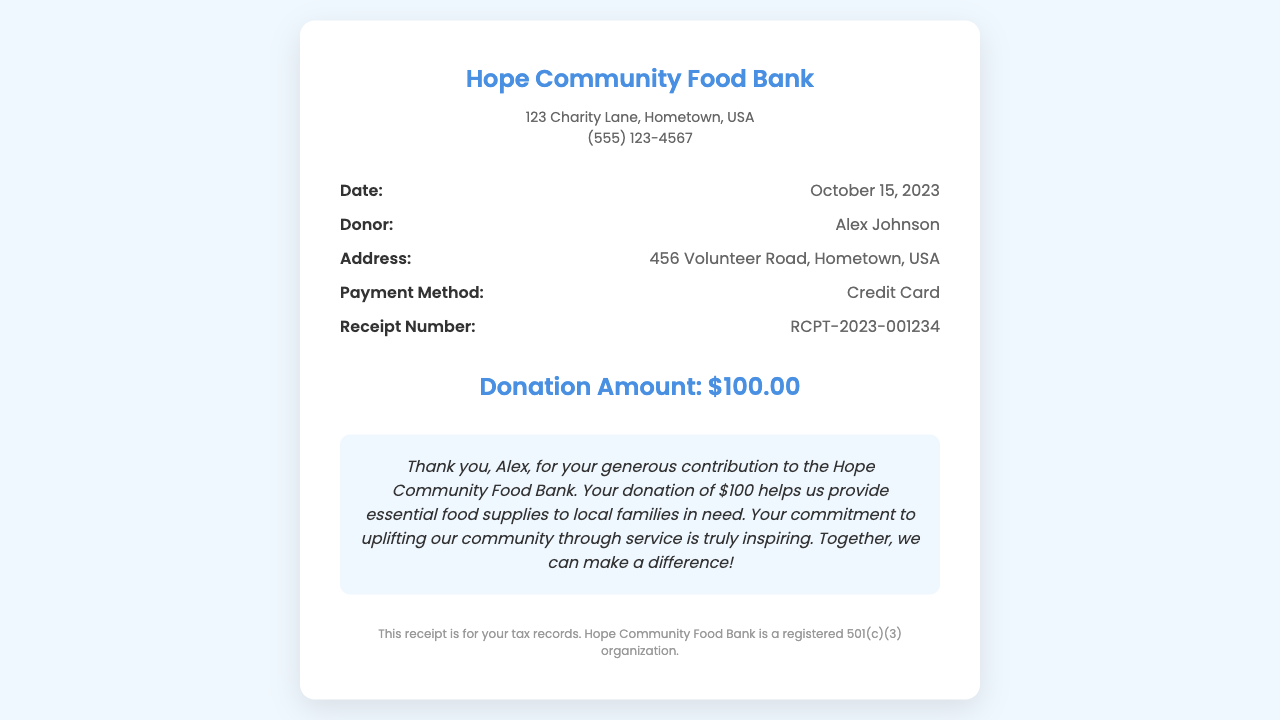What is the name of the organization? The document specifies the organization as "Hope Community Food Bank.”
Answer: Hope Community Food Bank What is the donation amount? The document mentions the donation amount clearly stated in the amount section, which is $100.00.
Answer: $100.00 Who made the donation? The document indicates that the donor's name is Alex Johnson.
Answer: Alex Johnson What is the receipt number? The receipt number is provided in the details section, formatted as RCPT-2023-001234.
Answer: RCPT-2023-001234 What date was the donation made? The donation date is explicitly listed in the document as October 15, 2023.
Answer: October 15, 2023 What is the payment method used for the donation? The document states the payment method as "Credit Card."
Answer: Credit Card What is the message conveyed to the donor? The document includes a message thanking the donor, emphasizing the impact of the contribution on the community.
Answer: Thank you, Alex, for your generous contribution to the Hope Community Food Bank How does the organization express appreciation for donations? The organization expresses appreciation by acknowledging the donation's impact on providing food supplies and inspiring community service.
Answer: Your commitment to uplifting our community through service is truly inspiring Is this receipt for tax records? The footer of the document confirms that this receipt is for tax records.
Answer: Yes 